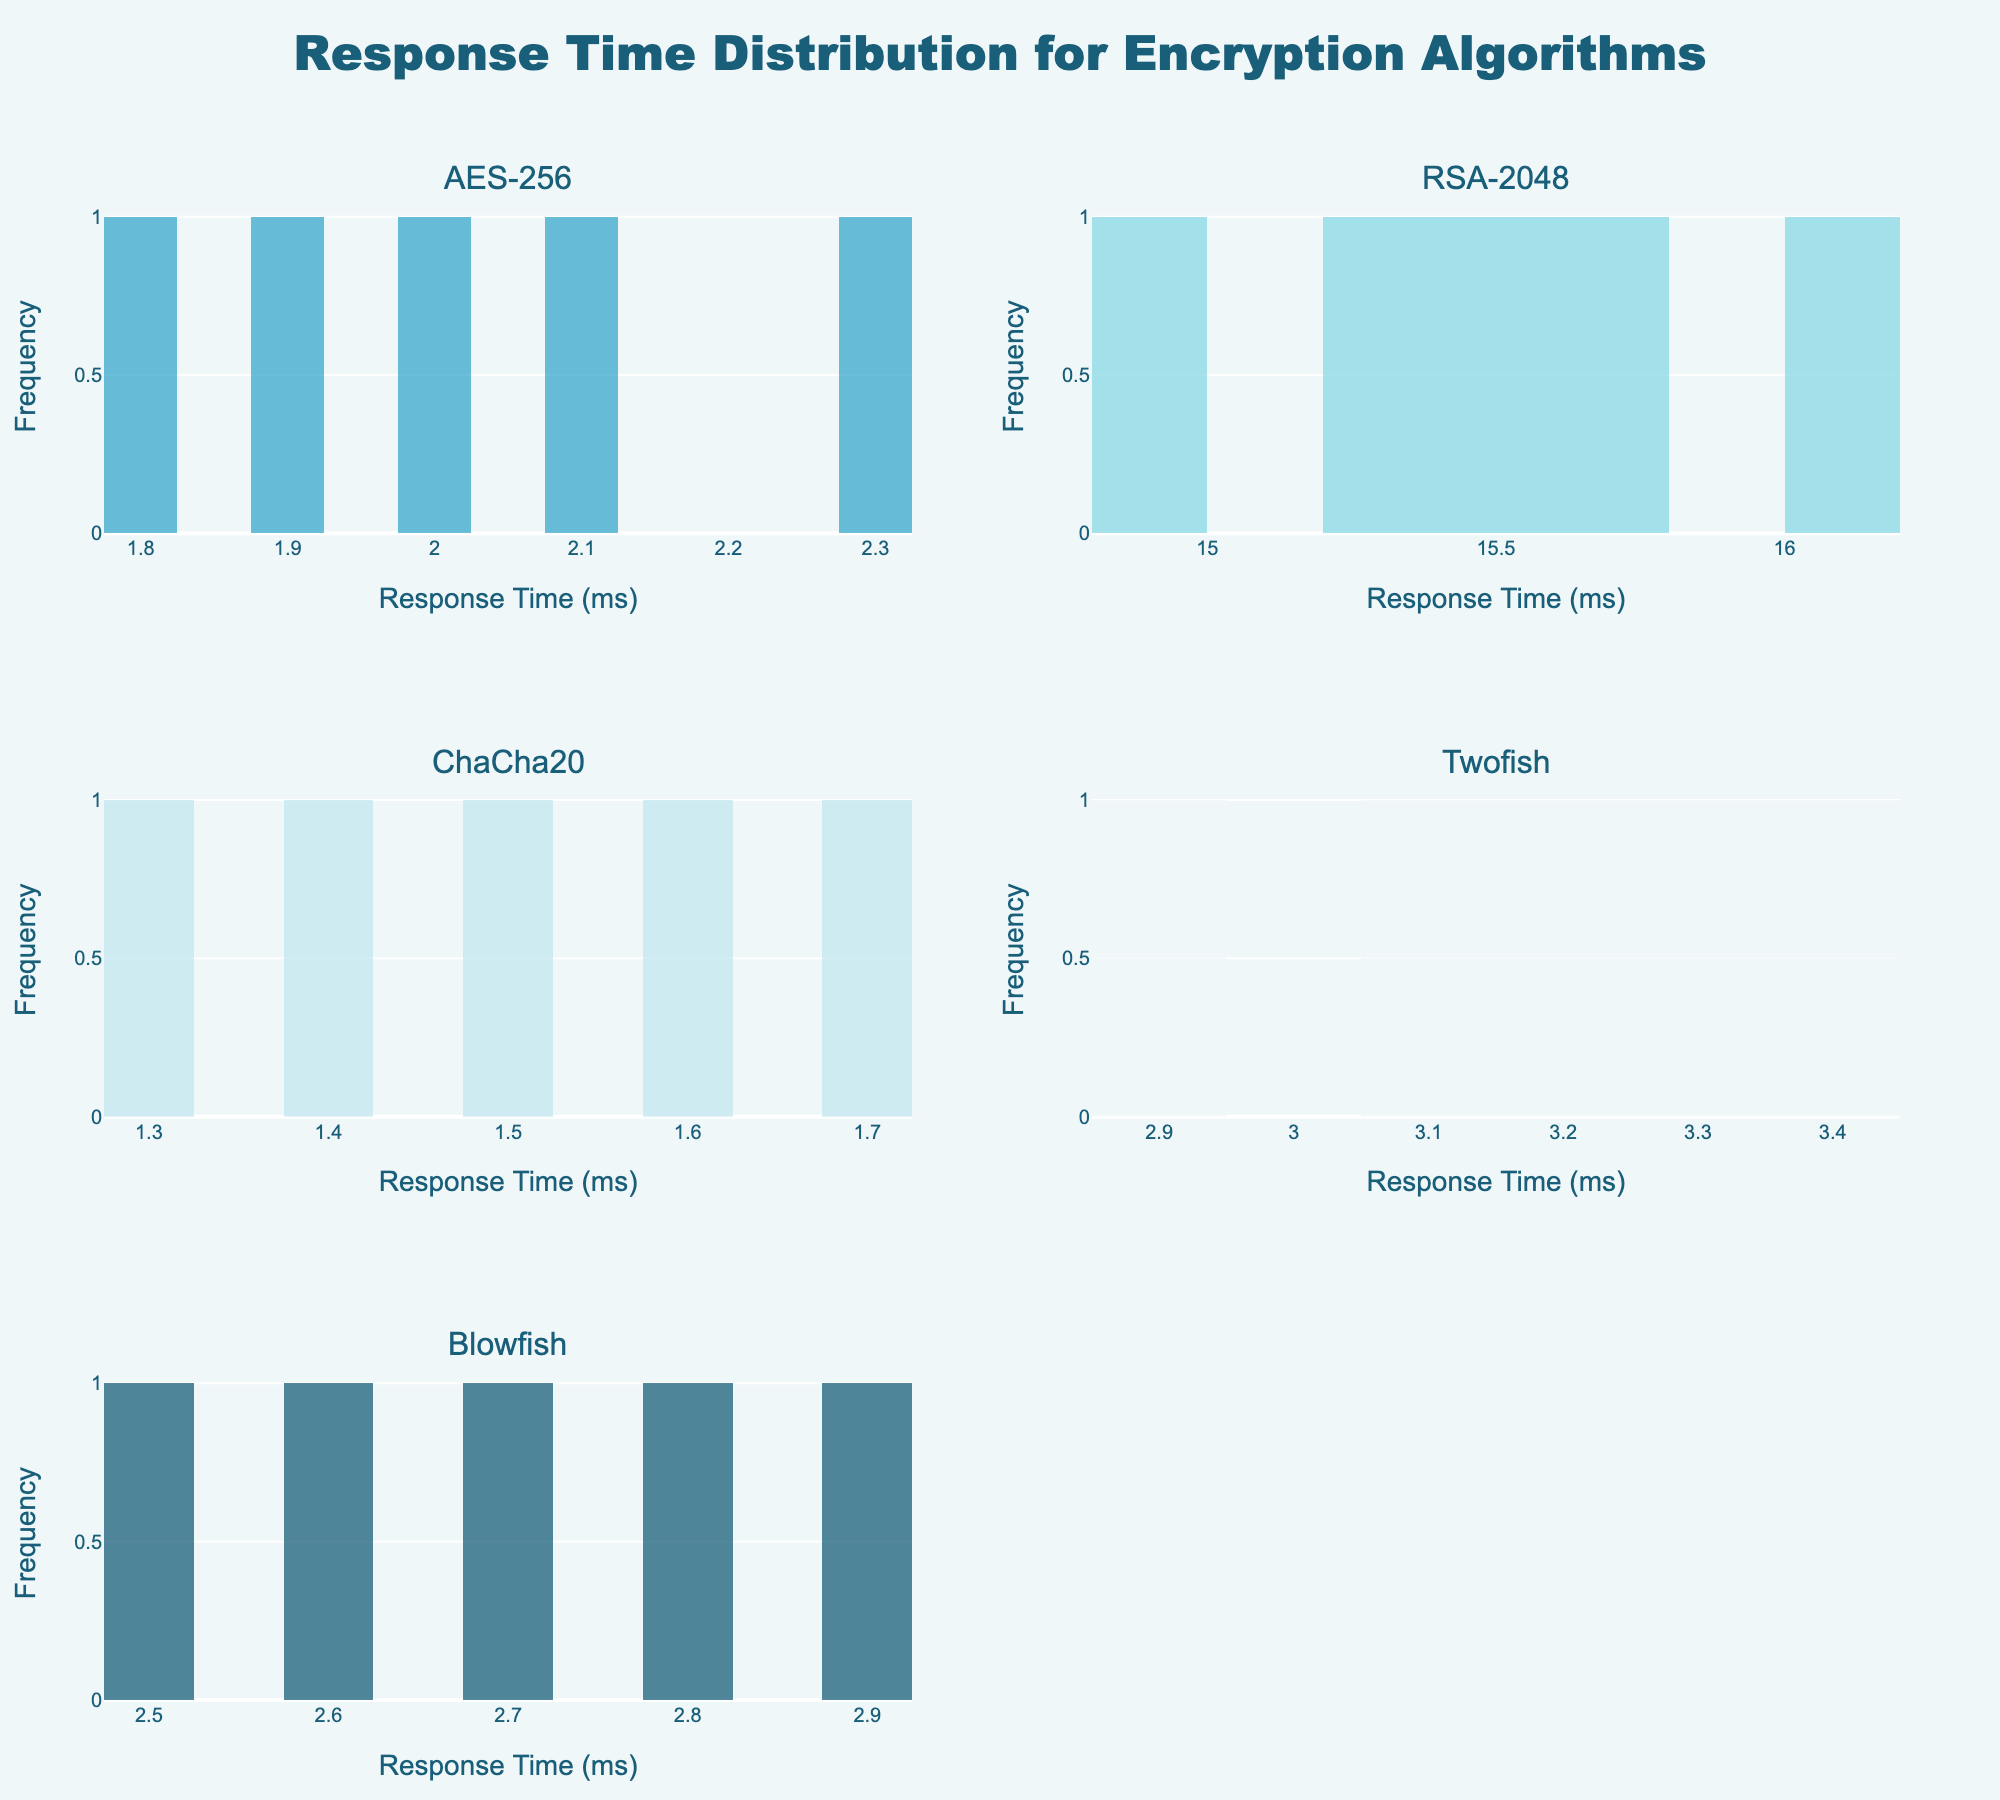What is the title of the plot? The title is located at the top-center of the plot. From the figure's description, the title is "Response Time Distribution for Encryption Algorithms".
Answer: Response Time Distribution for Encryption Algorithms What are the x-axis and y-axis labels for each subplot? Each subplot shares the same x-axis and y-axis labels. The x-axis is labeled "Response Time (ms)" and the y-axis is labeled "Frequency".
Answer: Response Time (ms) and Frequency Which encryption algorithm has the highest response time range? By glancing at the x-axis of each subplot, the RSA-2048 algorithm has response times ranging from about 14.8 ms to 16.1 ms, which is the highest compared to other algorithms.
Answer: RSA-2048 What is the median response time for the AES-256 algorithm? The response time data for AES-256 in the provided data set is {2.1, 1.8, 2.3, 2.0, 1.9}. When ordered, it is {1.8, 1.9, 2.0, 2.1, 2.3}, making the median value the middle number, which is 2.0 ms.
Answer: 2.0 ms Which algorithm shows a response time distribution centered around 1.5 ms? The central value can be observed by finding the peak of the histogram bars around specific values. The subplot for ChaCha20 has peaks around 1.5 ms.
Answer: ChaCha20 Between AES-256 and Blowfish, which algorithm has a more concentrated response time distribution? Comparing the two histograms, AES-256 has response times spread between 1.8 ms to 2.3 ms, while Blowfish has response times from 2.5 ms to 2.9 ms. Blowfish's range is narrower, making it more concentrated.
Answer: Blowfish For the Twofish algorithm, what is the range of response times shown? The range of response times for Twofish can be seen by looking at the x-axis limits for the corresponding subplot. The times range from 2.9 ms to 3.4 ms.
Answer: 2.9 ms to 3.4 ms How does the median response time for ChaCha20 compare to that of RSA-2048? The median for ChaCha20 can be calculated from the data set {1.5, 1.3, 1.6, 1.4, 1.7} which is 1.5 ms. For RSA-2048, the data set {15.3, 14.8, 16.1, 15.7, 15.5} gives a median of 15.5 ms. Comparing these, RSA-2048’s median is much higher.
Answer: RSA-2048’s median is higher Which algorithm has the most symmetrical histogram? By looking at the shape of each histogram, ChaCha20's histogram is the most symmetrical as it evenly spreads around its central value.
Answer: ChaCha20 What can be said about the response time distribution of the AES-256 algorithm compared to Twofish? Observing the histograms, both AES-256 and Twofish have a somewhat similar distribution pattern; however, AES-256's response time distribution is slightly broader than that of Twofish.
Answer: AES-256 has a slightly broader distribution than Twofish 